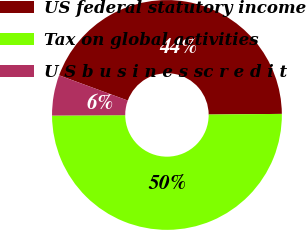<chart> <loc_0><loc_0><loc_500><loc_500><pie_chart><fcel>US federal statutory income<fcel>Tax on global activities<fcel>U S b u s i n e s sc r e d i t<nl><fcel>44.25%<fcel>50.06%<fcel>5.69%<nl></chart> 